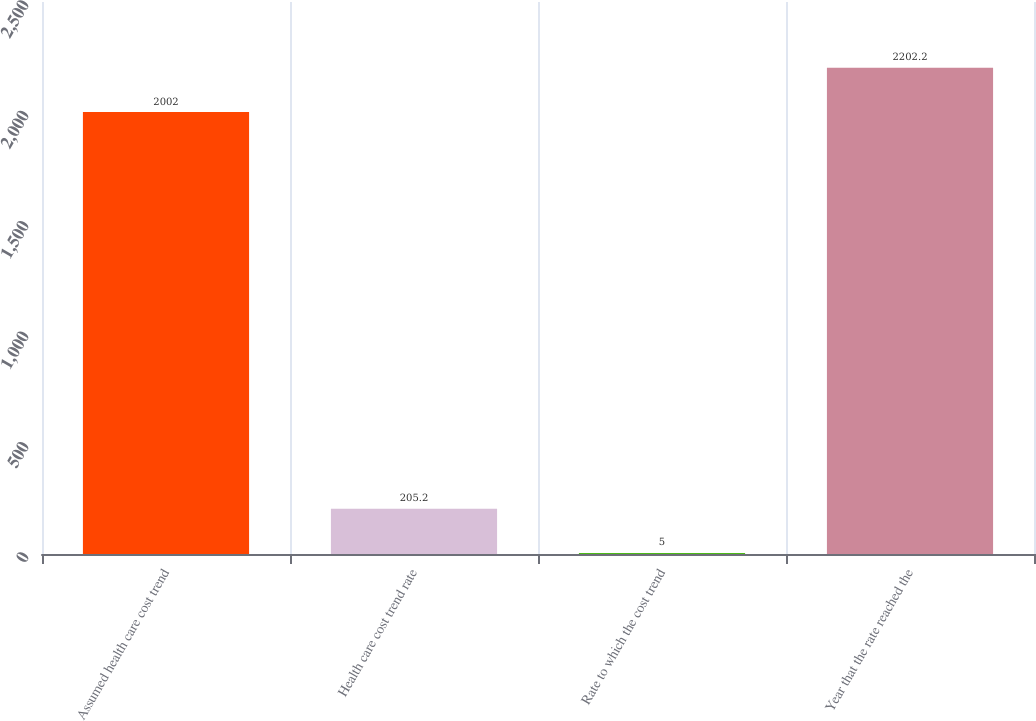<chart> <loc_0><loc_0><loc_500><loc_500><bar_chart><fcel>Assumed health care cost trend<fcel>Health care cost trend rate<fcel>Rate to which the cost trend<fcel>Year that the rate reached the<nl><fcel>2002<fcel>205.2<fcel>5<fcel>2202.2<nl></chart> 